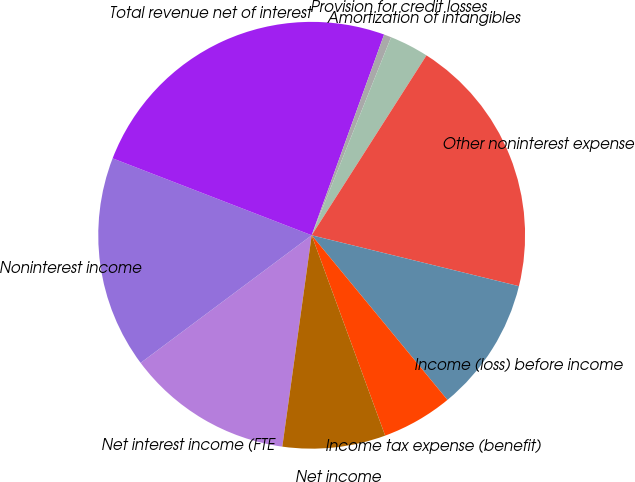Convert chart. <chart><loc_0><loc_0><loc_500><loc_500><pie_chart><fcel>Net interest income (FTE<fcel>Noninterest income<fcel>Total revenue net of interest<fcel>Provision for credit losses<fcel>Amortization of intangibles<fcel>Other noninterest expense<fcel>Income (loss) before income<fcel>Income tax expense (benefit)<fcel>Net income<nl><fcel>12.6%<fcel>16.07%<fcel>24.64%<fcel>0.56%<fcel>2.97%<fcel>19.79%<fcel>10.19%<fcel>5.38%<fcel>7.79%<nl></chart> 